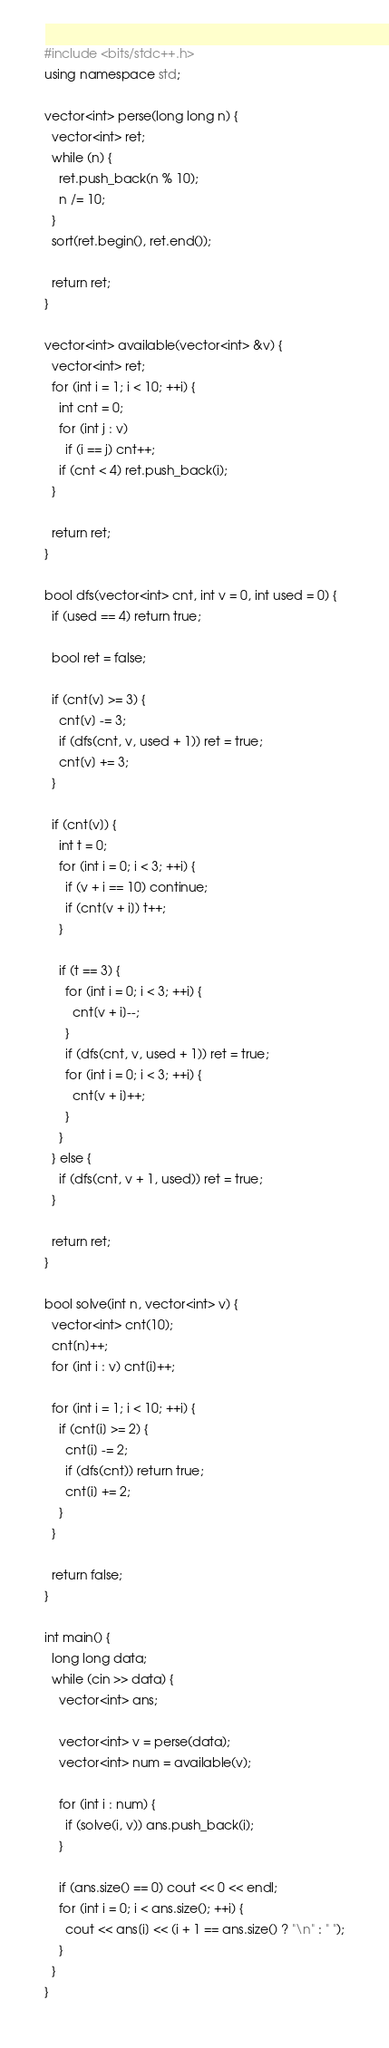Convert code to text. <code><loc_0><loc_0><loc_500><loc_500><_C++_>#include <bits/stdc++.h>
using namespace std;

vector<int> perse(long long n) {
  vector<int> ret;
  while (n) {
    ret.push_back(n % 10);
    n /= 10;
  }
  sort(ret.begin(), ret.end());

  return ret;
}

vector<int> available(vector<int> &v) {
  vector<int> ret;
  for (int i = 1; i < 10; ++i) {
    int cnt = 0;
    for (int j : v)
      if (i == j) cnt++;
    if (cnt < 4) ret.push_back(i);
  }

  return ret;
}

bool dfs(vector<int> cnt, int v = 0, int used = 0) {
  if (used == 4) return true;

  bool ret = false;

  if (cnt[v] >= 3) {
    cnt[v] -= 3;
    if (dfs(cnt, v, used + 1)) ret = true;
    cnt[v] += 3;
  }

  if (cnt[v]) {
    int t = 0;
    for (int i = 0; i < 3; ++i) {
      if (v + i == 10) continue;
      if (cnt[v + i]) t++;
    }

    if (t == 3) {
      for (int i = 0; i < 3; ++i) {
        cnt[v + i]--;
      }
      if (dfs(cnt, v, used + 1)) ret = true;
      for (int i = 0; i < 3; ++i) {
        cnt[v + i]++;
      }
    }
  } else {
    if (dfs(cnt, v + 1, used)) ret = true;
  }

  return ret;
}

bool solve(int n, vector<int> v) {
  vector<int> cnt(10);
  cnt[n]++;
  for (int i : v) cnt[i]++;

  for (int i = 1; i < 10; ++i) {
    if (cnt[i] >= 2) {
      cnt[i] -= 2;
      if (dfs(cnt)) return true;
      cnt[i] += 2;
    }
  }

  return false;
}

int main() {
  long long data;
  while (cin >> data) {
    vector<int> ans;

    vector<int> v = perse(data);
    vector<int> num = available(v);

    for (int i : num) {
      if (solve(i, v)) ans.push_back(i);
    }

    if (ans.size() == 0) cout << 0 << endl;
    for (int i = 0; i < ans.size(); ++i) {
      cout << ans[i] << (i + 1 == ans.size() ? "\n" : " ");
    }
  }
}</code> 